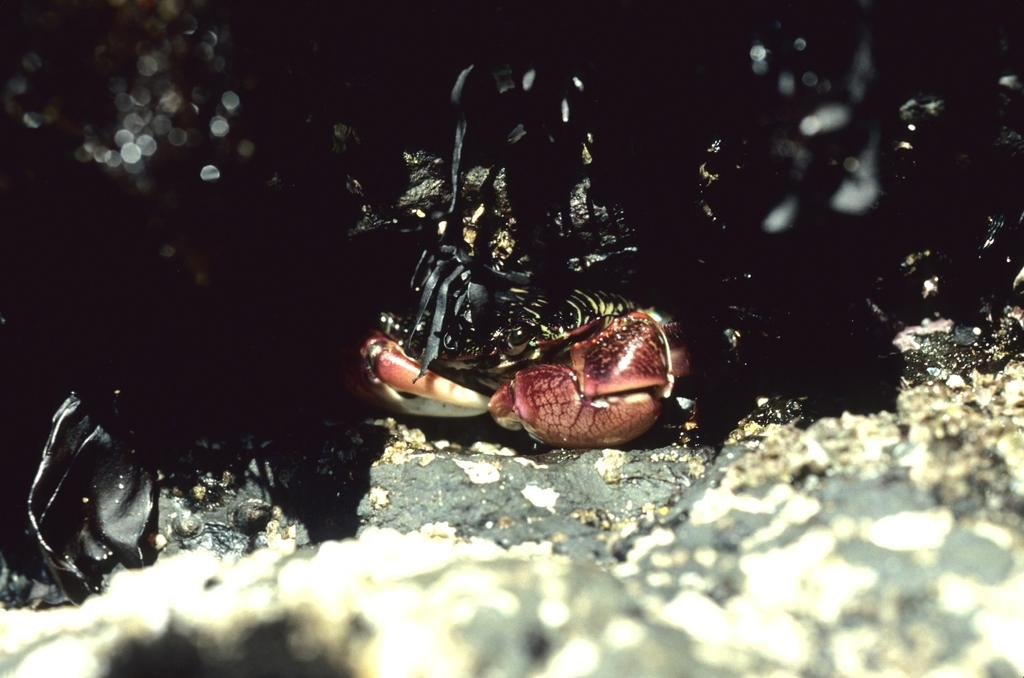What type of creature is present in the image? There is an animal in the image. What color is the animal in the image? The animal is black in color. What type of authority does the animal have in the image? The image does not depict any authority figures or situations, so it cannot be determined if the animal has any authority. 